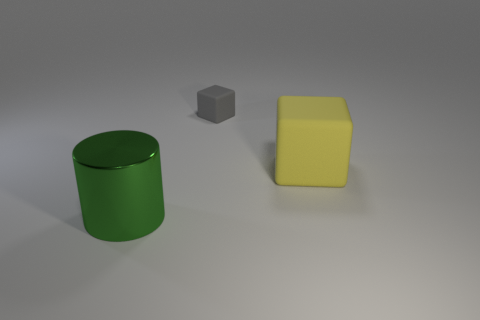Add 3 small yellow metallic cubes. How many objects exist? 6 Subtract all blocks. How many objects are left? 1 Subtract 1 yellow blocks. How many objects are left? 2 Subtract all tiny blocks. Subtract all green objects. How many objects are left? 1 Add 1 large yellow rubber cubes. How many large yellow rubber cubes are left? 2 Add 1 large green shiny objects. How many large green shiny objects exist? 2 